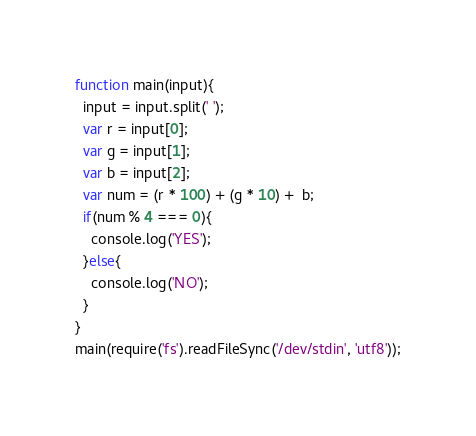<code> <loc_0><loc_0><loc_500><loc_500><_JavaScript_>function main(input){
  input = input.split(' ');
  var r = input[0];
  var g = input[1];
  var b = input[2];
  var num = (r * 100) + (g * 10) +  b;
  if(num % 4 === 0){
    console.log('YES');
  }else{
    console.log('NO');
  }
}
main(require('fs').readFileSync('/dev/stdin', 'utf8'));</code> 